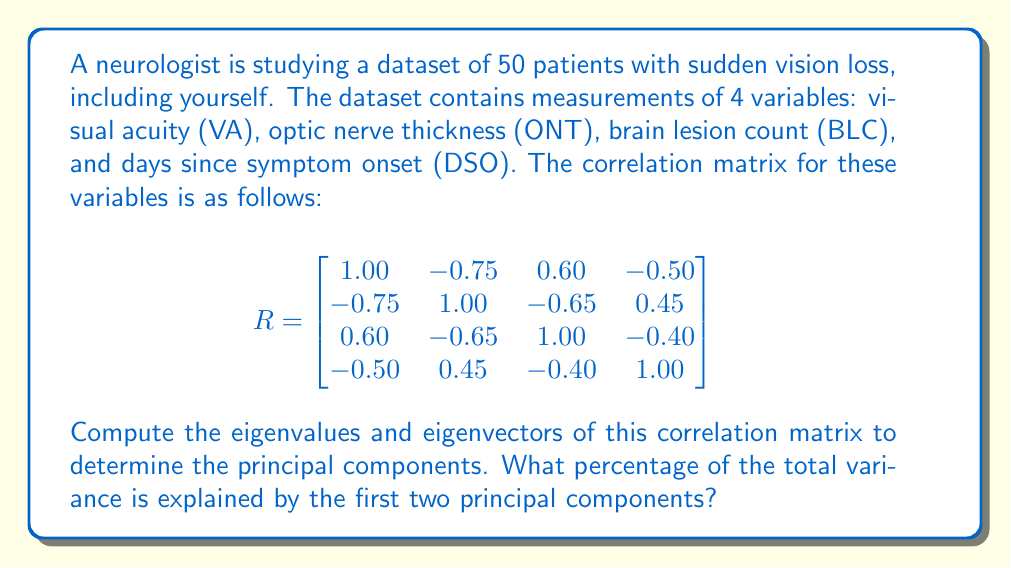Can you solve this math problem? To compute the principal components, we need to find the eigenvalues and eigenvectors of the correlation matrix. The steps are as follows:

1. Find the eigenvalues by solving the characteristic equation:
   $\det(R - \lambda I) = 0$

2. Calculate the eigenvectors corresponding to each eigenvalue.

3. Order the eigenvalues from largest to smallest. The corresponding eigenvectors are the principal components in order of importance.

4. Calculate the proportion of variance explained by each component.

Let's proceed with the calculations:

1. Solving the characteristic equation (using a computer algebra system):
   The eigenvalues are approximately:
   $\lambda_1 \approx 2.7546$
   $\lambda_2 \approx 0.7454$
   $\lambda_3 \approx 0.3162$
   $\lambda_4 \approx 0.1838$

2. The corresponding eigenvectors (normalized) are:
   $v_1 \approx [-0.5657, 0.5657, -0.5303, 0.2726]$
   $v_2 \approx [-0.1291, -0.1291, 0.3873, 0.9055]$
   $v_3 \approx [0.5303, 0.5303, 0.6604, -0.0990]$
   $v_4 \approx [-0.6164, -0.6164, 0.3615, -0.3164]$

3. The eigenvalues are already in descending order, so these eigenvectors represent the principal components in order of importance.

4. To calculate the proportion of variance explained by each component:
   Total variance = sum of eigenvalues = 4 (since it's a correlation matrix)
   
   Proportion of variance explained by PC1 = $\frac{2.7546}{4} \approx 0.6887$ or 68.87%
   Proportion of variance explained by PC2 = $\frac{0.7454}{4} \approx 0.1864$ or 18.64%

   The cumulative proportion of variance explained by the first two PCs:
   $0.6887 + 0.1864 = 0.8751$ or 87.51%
Answer: The first two principal components explain approximately 87.51% of the total variance in the dataset. 